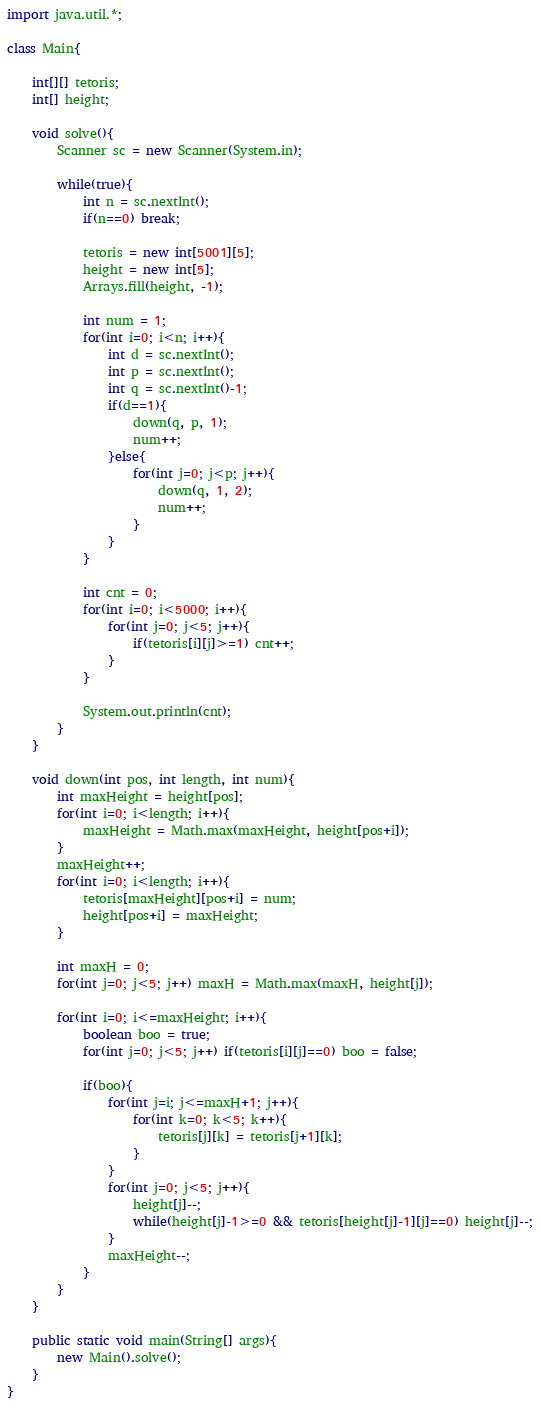<code> <loc_0><loc_0><loc_500><loc_500><_Java_>import java.util.*;

class Main{

    int[][] tetoris;
    int[] height;

    void solve(){
        Scanner sc = new Scanner(System.in);

        while(true){
            int n = sc.nextInt();
            if(n==0) break;

            tetoris = new int[5001][5];
            height = new int[5];
            Arrays.fill(height, -1);

            int num = 1;
            for(int i=0; i<n; i++){
                int d = sc.nextInt();
                int p = sc.nextInt();
                int q = sc.nextInt()-1;
                if(d==1){
                    down(q, p, 1);
                    num++;
                }else{
                    for(int j=0; j<p; j++){
                        down(q, 1, 2);
                        num++;
                    }
                }
            }

            int cnt = 0;
            for(int i=0; i<5000; i++){
                for(int j=0; j<5; j++){
                    if(tetoris[i][j]>=1) cnt++;
                }
            }

            System.out.println(cnt);
        }
    }

    void down(int pos, int length, int num){
        int maxHeight = height[pos];
        for(int i=0; i<length; i++){
            maxHeight = Math.max(maxHeight, height[pos+i]);
        }
        maxHeight++;
        for(int i=0; i<length; i++){
            tetoris[maxHeight][pos+i] = num;
            height[pos+i] = maxHeight;
        }

        int maxH = 0;
        for(int j=0; j<5; j++) maxH = Math.max(maxH, height[j]);

        for(int i=0; i<=maxHeight; i++){
            boolean boo = true;
            for(int j=0; j<5; j++) if(tetoris[i][j]==0) boo = false;
            
            if(boo){
                for(int j=i; j<=maxH+1; j++){
                    for(int k=0; k<5; k++){
                        tetoris[j][k] = tetoris[j+1][k];
                    }
                }
                for(int j=0; j<5; j++){
                    height[j]--;
                    while(height[j]-1>=0 && tetoris[height[j]-1][j]==0) height[j]--;
                }
                maxHeight--;
            }
        }        
    }

    public static void main(String[] args){
        new Main().solve();
    }
}</code> 